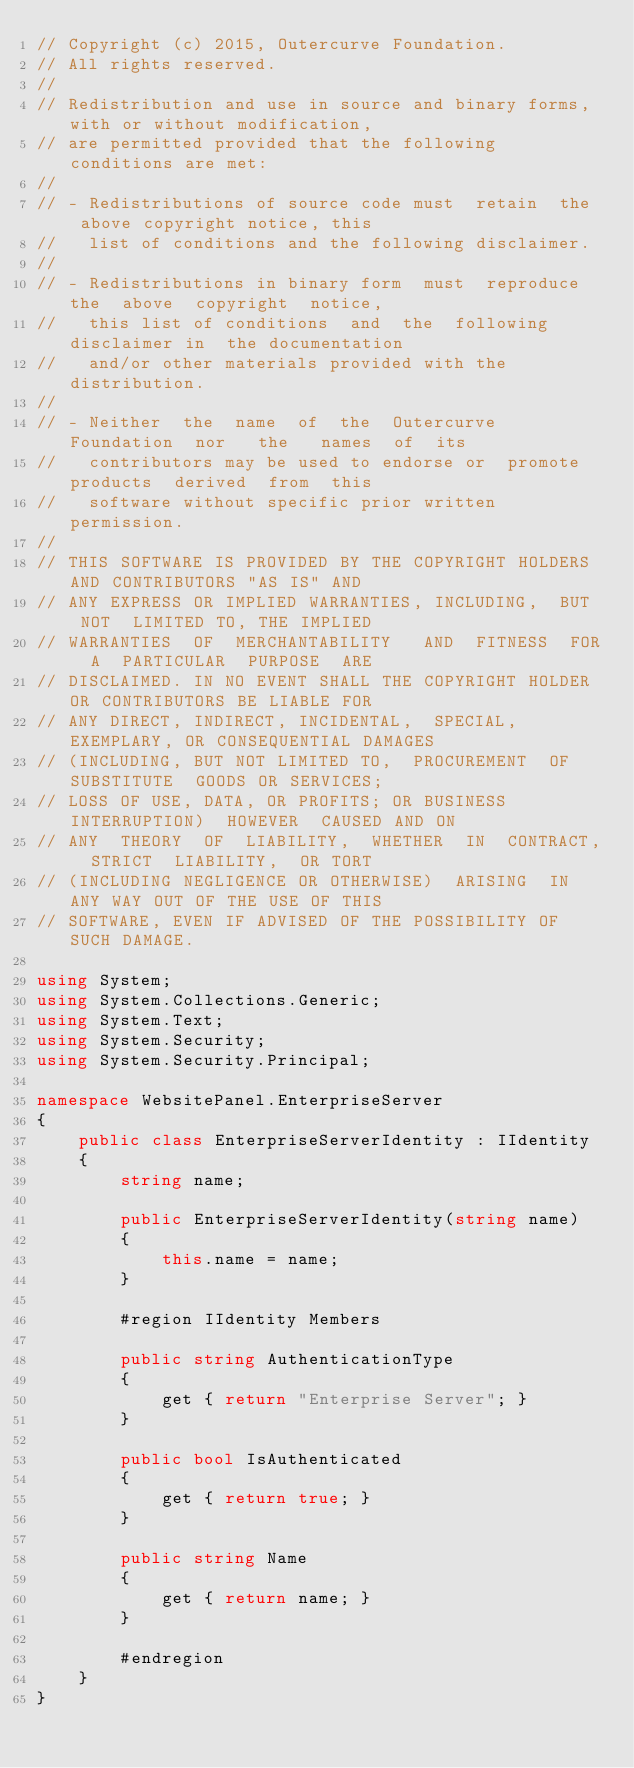Convert code to text. <code><loc_0><loc_0><loc_500><loc_500><_C#_>// Copyright (c) 2015, Outercurve Foundation.
// All rights reserved.
//
// Redistribution and use in source and binary forms, with or without modification,
// are permitted provided that the following conditions are met:
//
// - Redistributions of source code must  retain  the  above copyright notice, this
//   list of conditions and the following disclaimer.
//
// - Redistributions in binary form  must  reproduce the  above  copyright  notice,
//   this list of conditions  and  the  following  disclaimer in  the documentation
//   and/or other materials provided with the distribution.
//
// - Neither  the  name  of  the  Outercurve Foundation  nor   the   names  of  its
//   contributors may be used to endorse or  promote  products  derived  from  this
//   software without specific prior written permission.
//
// THIS SOFTWARE IS PROVIDED BY THE COPYRIGHT HOLDERS AND CONTRIBUTORS "AS IS" AND
// ANY EXPRESS OR IMPLIED WARRANTIES, INCLUDING,  BUT  NOT  LIMITED TO, THE IMPLIED
// WARRANTIES  OF  MERCHANTABILITY   AND  FITNESS  FOR  A  PARTICULAR  PURPOSE  ARE
// DISCLAIMED. IN NO EVENT SHALL THE COPYRIGHT HOLDER OR CONTRIBUTORS BE LIABLE FOR
// ANY DIRECT, INDIRECT, INCIDENTAL,  SPECIAL,  EXEMPLARY, OR CONSEQUENTIAL DAMAGES
// (INCLUDING, BUT NOT LIMITED TO,  PROCUREMENT  OF  SUBSTITUTE  GOODS OR SERVICES;
// LOSS OF USE, DATA, OR PROFITS; OR BUSINESS INTERRUPTION)  HOWEVER  CAUSED AND ON
// ANY  THEORY  OF  LIABILITY,  WHETHER  IN  CONTRACT,  STRICT  LIABILITY,  OR TORT
// (INCLUDING NEGLIGENCE OR OTHERWISE)  ARISING  IN  ANY WAY OUT OF THE USE OF THIS
// SOFTWARE, EVEN IF ADVISED OF THE POSSIBILITY OF SUCH DAMAGE.

using System;
using System.Collections.Generic;
using System.Text;
using System.Security;
using System.Security.Principal;

namespace WebsitePanel.EnterpriseServer
{
    public class EnterpriseServerIdentity : IIdentity
    {
        string name;

        public EnterpriseServerIdentity(string name)
        {
            this.name = name;
        }

        #region IIdentity Members

        public string AuthenticationType
        {
            get { return "Enterprise Server"; }
        }

        public bool IsAuthenticated
        {
            get { return true; }
        }

        public string Name
        {
            get { return name; }
        }

        #endregion
    }
}
</code> 